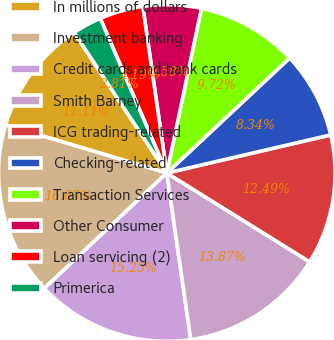Convert chart. <chart><loc_0><loc_0><loc_500><loc_500><pie_chart><fcel>In millions of dollars<fcel>Investment banking<fcel>Credit cards and bank cards<fcel>Smith Barney<fcel>ICG trading-related<fcel>Checking-related<fcel>Transaction Services<fcel>Other Consumer<fcel>Loan servicing (2)<fcel>Primerica<nl><fcel>11.11%<fcel>16.63%<fcel>15.25%<fcel>13.87%<fcel>12.49%<fcel>8.34%<fcel>9.72%<fcel>5.58%<fcel>4.19%<fcel>2.81%<nl></chart> 